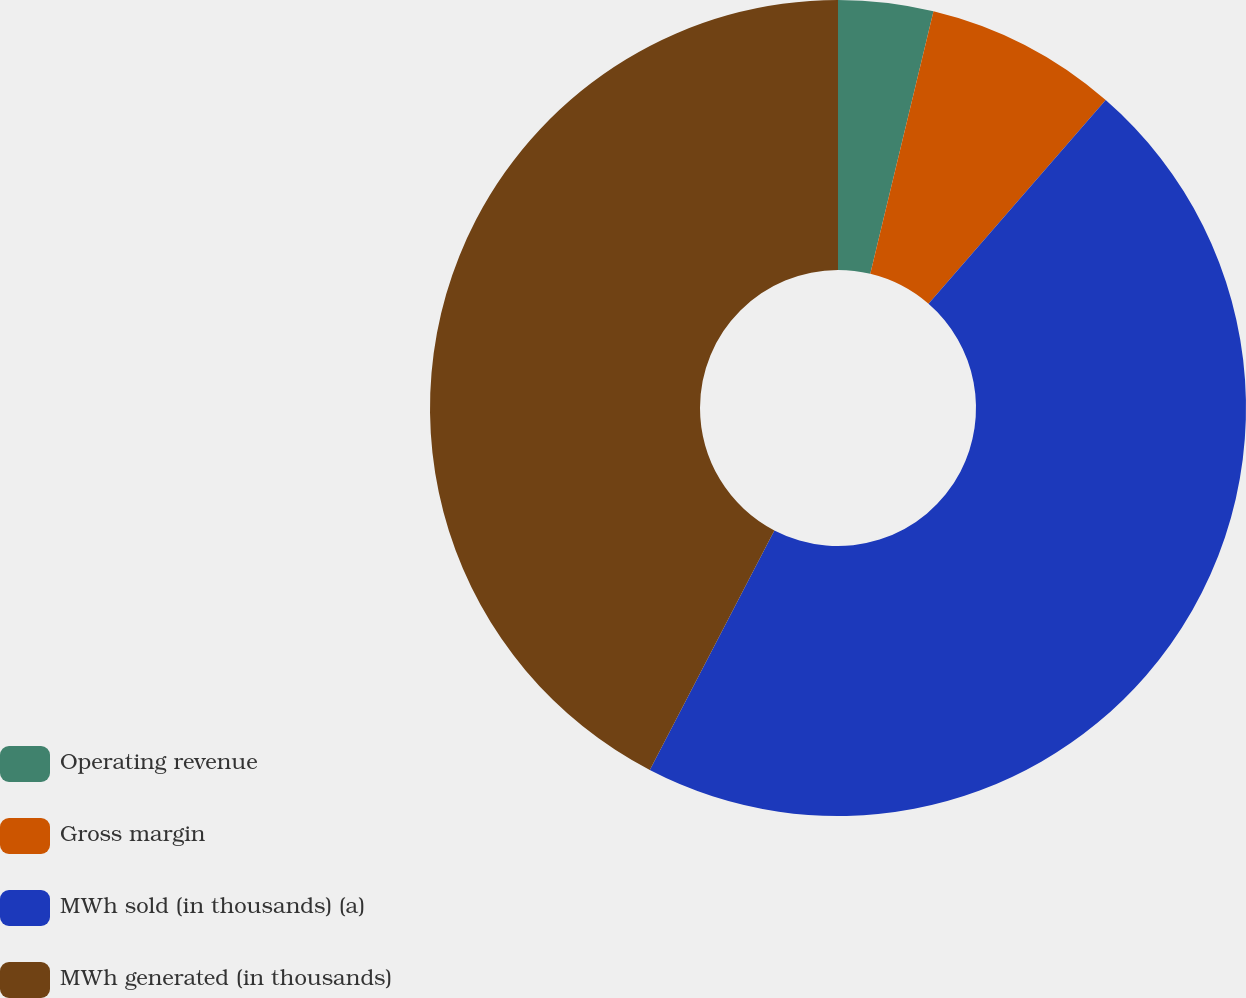Convert chart. <chart><loc_0><loc_0><loc_500><loc_500><pie_chart><fcel>Operating revenue<fcel>Gross margin<fcel>MWh sold (in thousands) (a)<fcel>MWh generated (in thousands)<nl><fcel>3.76%<fcel>7.63%<fcel>46.24%<fcel>42.37%<nl></chart> 